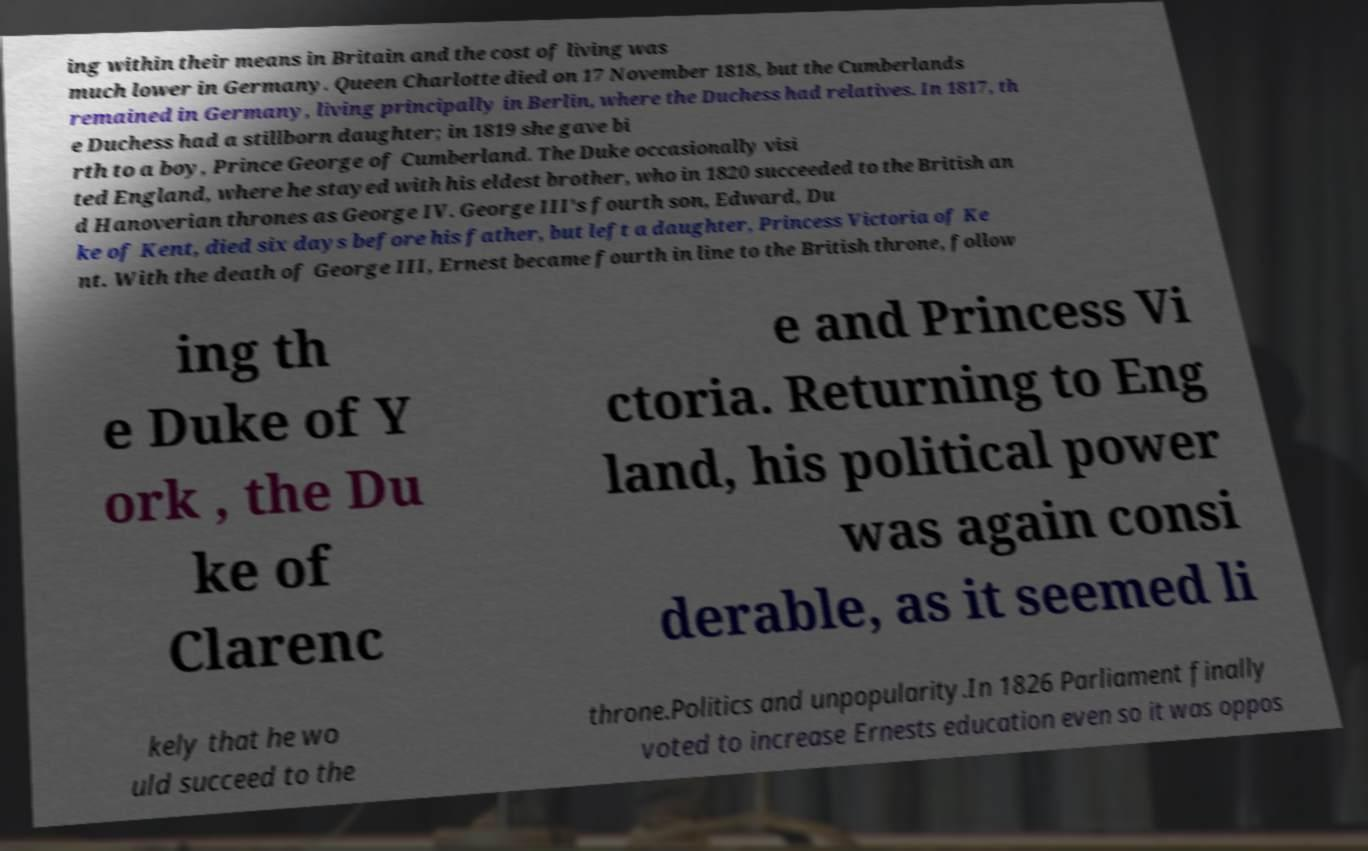For documentation purposes, I need the text within this image transcribed. Could you provide that? ing within their means in Britain and the cost of living was much lower in Germany. Queen Charlotte died on 17 November 1818, but the Cumberlands remained in Germany, living principally in Berlin, where the Duchess had relatives. In 1817, th e Duchess had a stillborn daughter; in 1819 she gave bi rth to a boy, Prince George of Cumberland. The Duke occasionally visi ted England, where he stayed with his eldest brother, who in 1820 succeeded to the British an d Hanoverian thrones as George IV. George III's fourth son, Edward, Du ke of Kent, died six days before his father, but left a daughter, Princess Victoria of Ke nt. With the death of George III, Ernest became fourth in line to the British throne, follow ing th e Duke of Y ork , the Du ke of Clarenc e and Princess Vi ctoria. Returning to Eng land, his political power was again consi derable, as it seemed li kely that he wo uld succeed to the throne.Politics and unpopularity.In 1826 Parliament finally voted to increase Ernests education even so it was oppos 